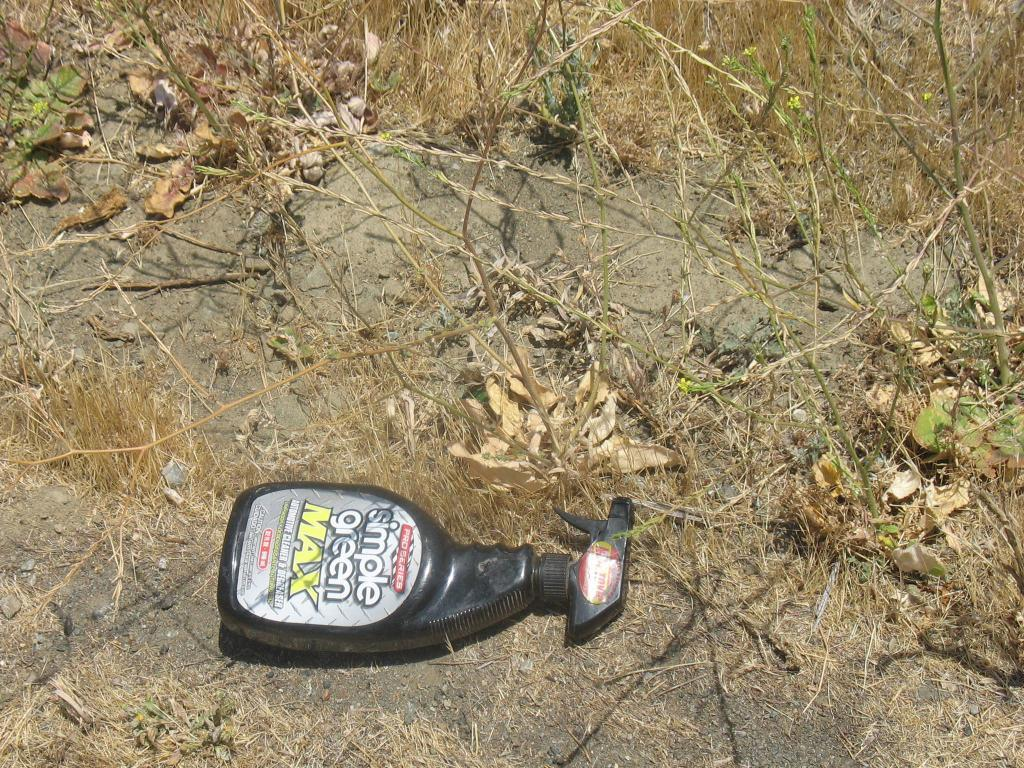What type of vegetation is present in the image? There are plants in the image. What is the condition of the grass in the image? There is dried grass in the image. What type of surface is visible in the image? There is soil in the image. What object is on the ground in the image? There is a bottle on the ground in the image. What can be read on the bottle in the image? There is text on the bottle in the image. How many books are stacked on the back of the plants in the image? There are no books present in the image; it only features plants, dried grass, soil, a bottle, and text on the bottle. 